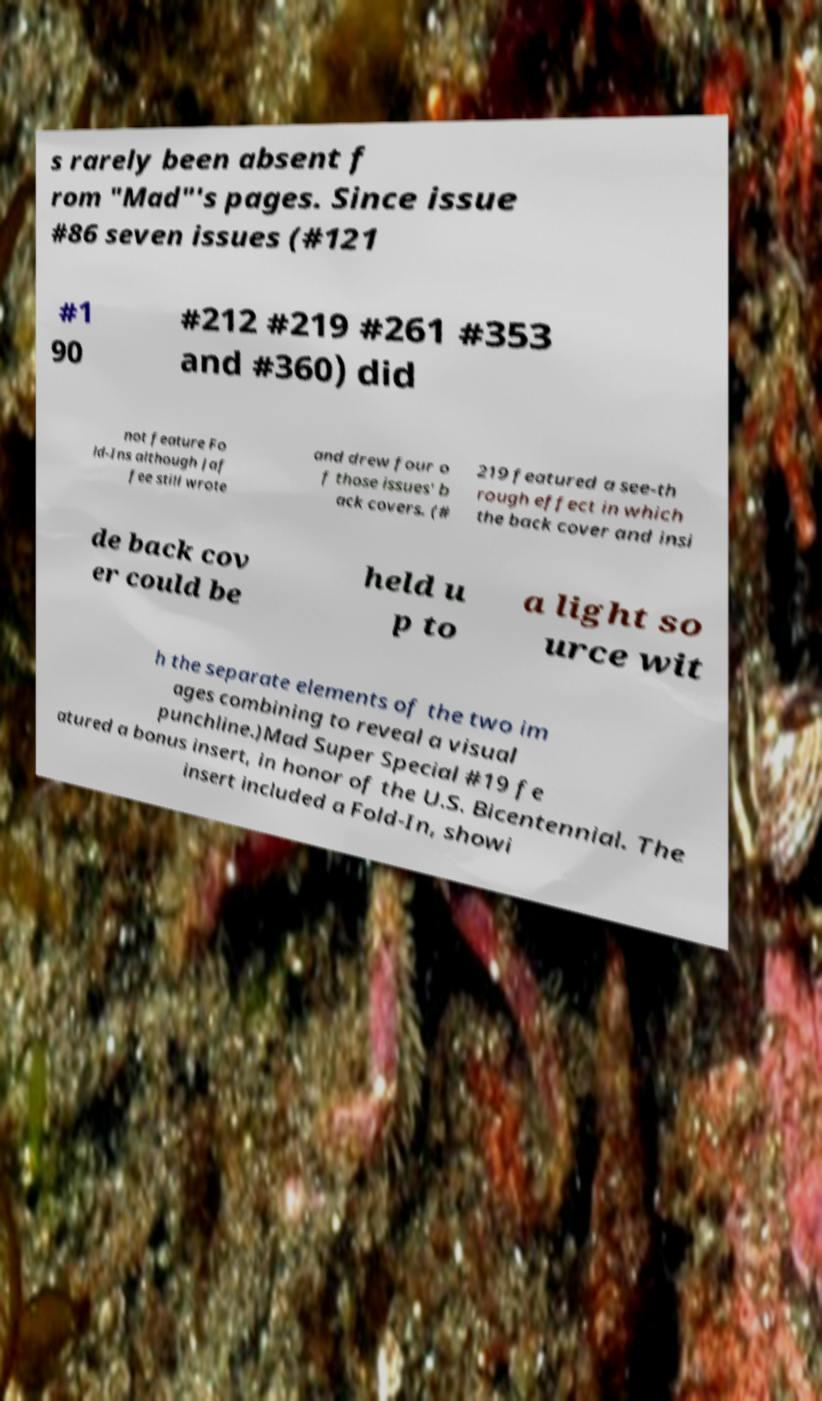Can you read and provide the text displayed in the image?This photo seems to have some interesting text. Can you extract and type it out for me? s rarely been absent f rom "Mad"'s pages. Since issue #86 seven issues (#121 #1 90 #212 #219 #261 #353 and #360) did not feature Fo ld-Ins although Jaf fee still wrote and drew four o f those issues' b ack covers. (# 219 featured a see-th rough effect in which the back cover and insi de back cov er could be held u p to a light so urce wit h the separate elements of the two im ages combining to reveal a visual punchline.)Mad Super Special #19 fe atured a bonus insert, in honor of the U.S. Bicentennial. The insert included a Fold-In, showi 